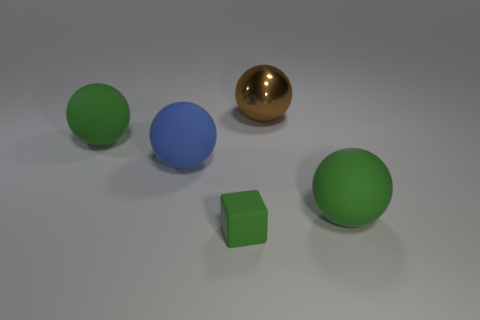Subtract 1 spheres. How many spheres are left? 3 Add 3 small blue metallic blocks. How many objects exist? 8 Subtract all balls. How many objects are left? 1 Subtract all big green balls. Subtract all small green matte cubes. How many objects are left? 2 Add 1 blue spheres. How many blue spheres are left? 2 Add 3 small matte blocks. How many small matte blocks exist? 4 Subtract 0 gray cylinders. How many objects are left? 5 